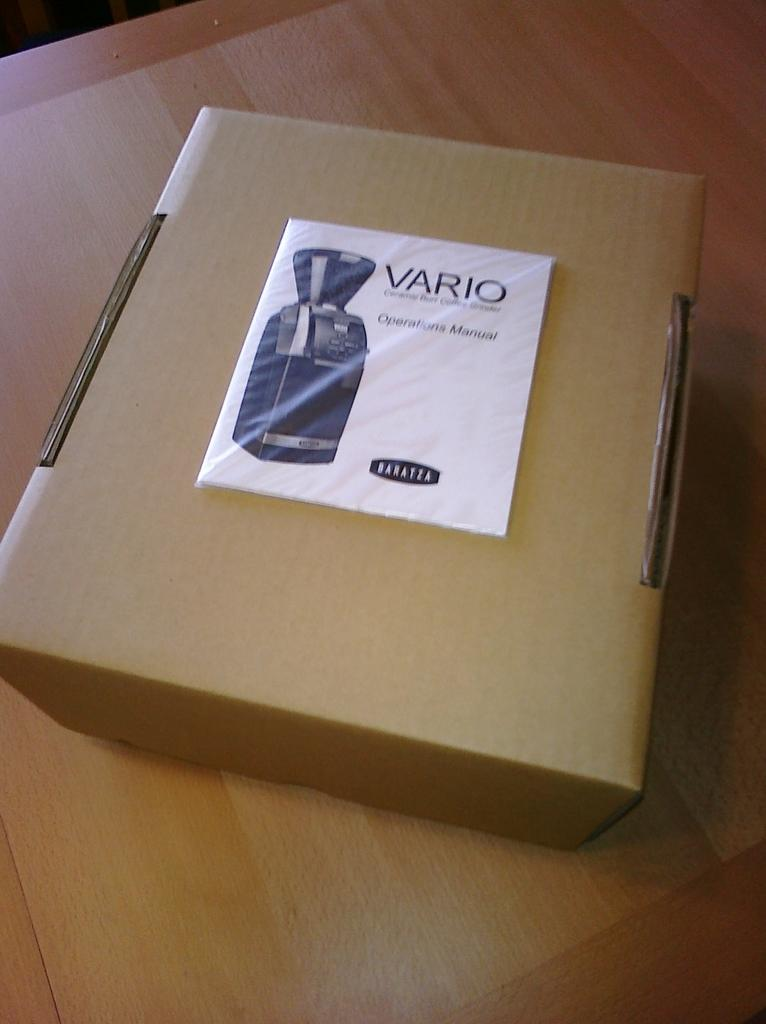<image>
Relay a brief, clear account of the picture shown. a box with the words Vario on it on a table 